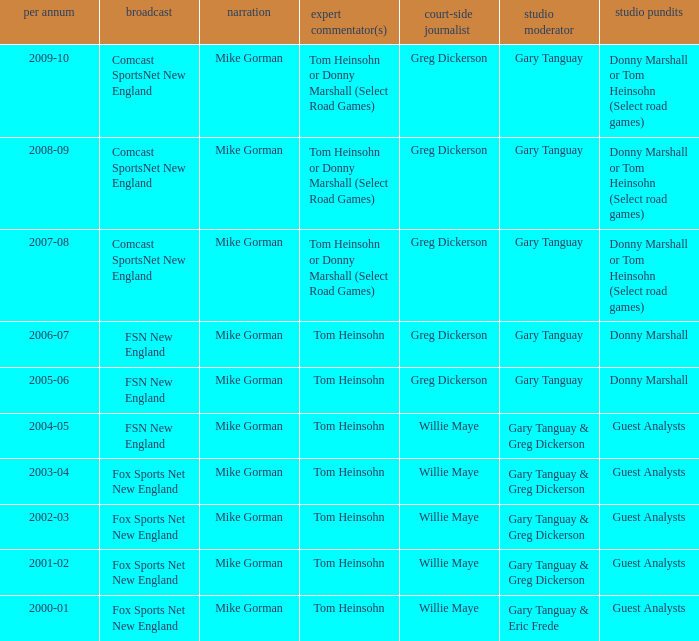WHich Studio analysts has a Studio host of gary tanguay in 2009-10? Donny Marshall or Tom Heinsohn (Select road games). 